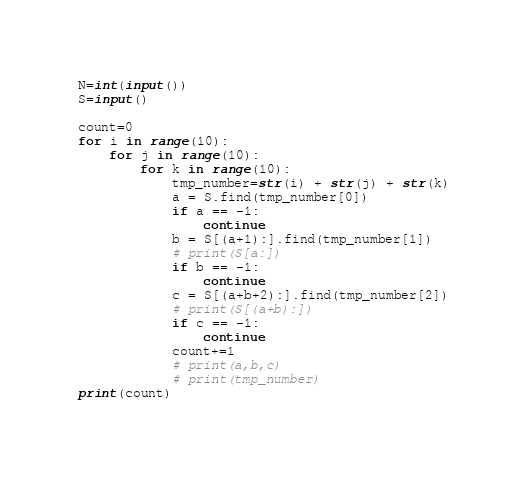Convert code to text. <code><loc_0><loc_0><loc_500><loc_500><_Python_>N=int(input())
S=input()

count=0
for i in range(10):
    for j in range(10):
        for k in range(10):
            tmp_number=str(i) + str(j) + str(k)
            a = S.find(tmp_number[0])
            if a == -1:
                continue
            b = S[(a+1):].find(tmp_number[1])
            # print(S[a:])
            if b == -1:
                continue
            c = S[(a+b+2):].find(tmp_number[2])
            # print(S[(a+b):])
            if c == -1:
                continue
            count+=1
            # print(a,b,c)
            # print(tmp_number)
print(count)
</code> 